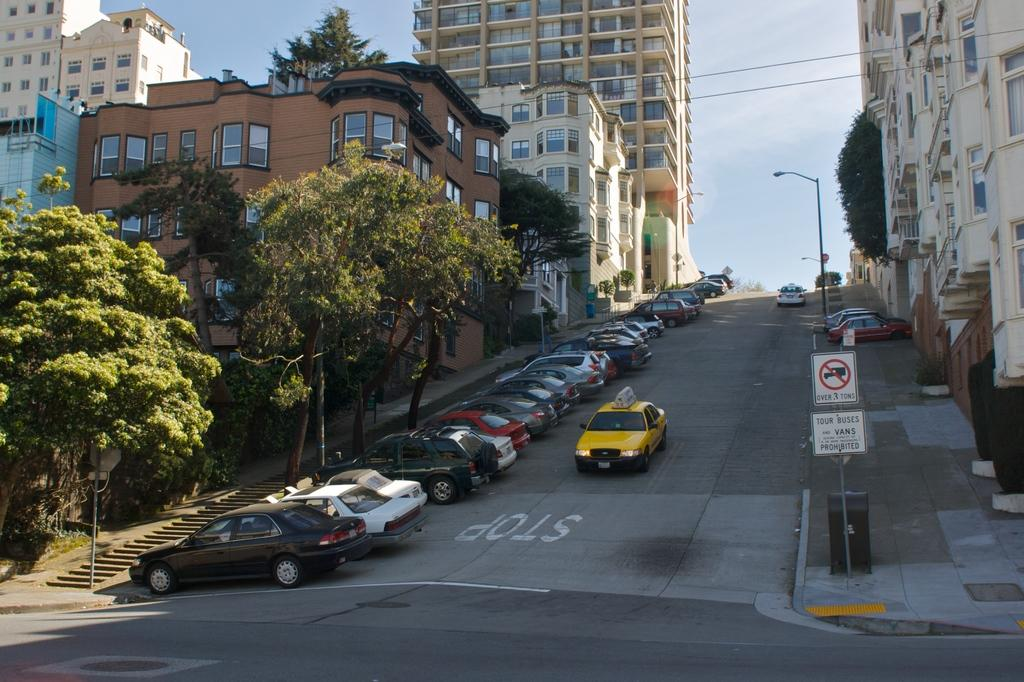<image>
Provide a brief description of the given image. Trucks over 3 tons are not allowed on this steep road. 